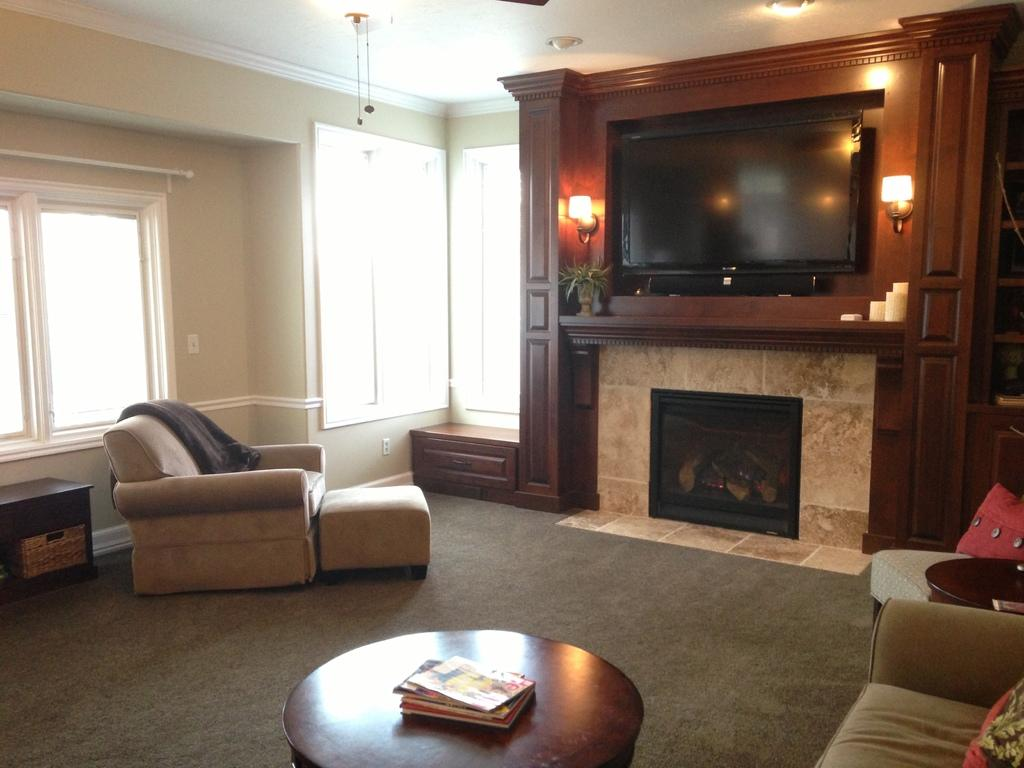What can be seen through the window in the image? The facts provided do not specify what can be seen through the window. What type of furniture is in the image? There is a sofa and a table in the image. What items are on the table in the image? There are books on the table in the image. What type of electronic device is in the image? There is a TV in the image. What type of lighting is visible in the image? There are lights visible in the image. What type of church can be seen in the image? There is no church present in the image. Who is the creator of the sofa in the image? The facts provided do not specify the creator of the sofa. How old is the boy sitting on the sofa in the image? There is no boy present in the image. 